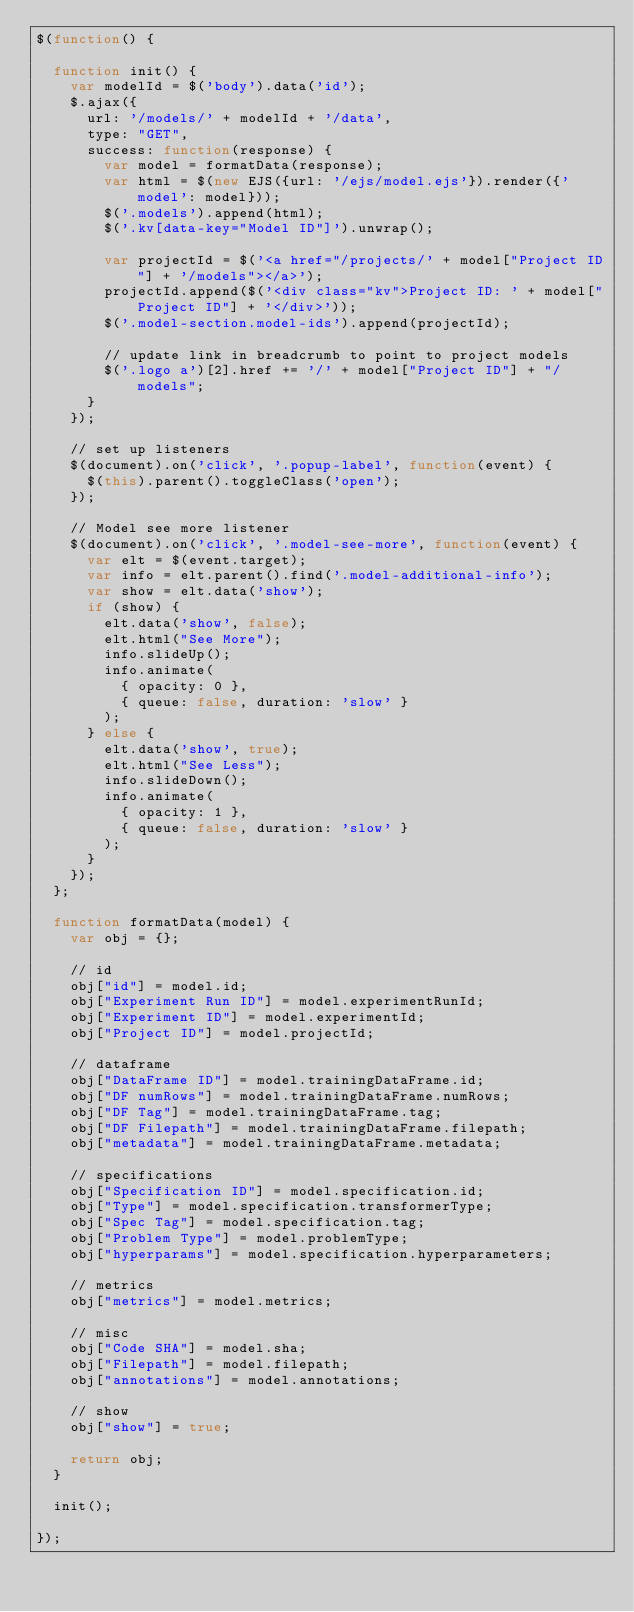Convert code to text. <code><loc_0><loc_0><loc_500><loc_500><_JavaScript_>$(function() {

  function init() {
    var modelId = $('body').data('id');
    $.ajax({
      url: '/models/' + modelId + '/data',
      type: "GET",
      success: function(response) {
        var model = formatData(response);
        var html = $(new EJS({url: '/ejs/model.ejs'}).render({'model': model}));
        $('.models').append(html);
        $('.kv[data-key="Model ID"]').unwrap();

        var projectId = $('<a href="/projects/' + model["Project ID"] + '/models"></a>');
        projectId.append($('<div class="kv">Project ID: ' + model["Project ID"] + '</div>'));
        $('.model-section.model-ids').append(projectId);

        // update link in breadcrumb to point to project models
        $('.logo a')[2].href += '/' + model["Project ID"] + "/models";
      }
    });

    // set up listeners
    $(document).on('click', '.popup-label', function(event) {
      $(this).parent().toggleClass('open');
    });

    // Model see more listener
    $(document).on('click', '.model-see-more', function(event) {
      var elt = $(event.target);
      var info = elt.parent().find('.model-additional-info');
      var show = elt.data('show');
      if (show) {
        elt.data('show', false);
        elt.html("See More");
        info.slideUp();
        info.animate(
          { opacity: 0 },
          { queue: false, duration: 'slow' }
        );
      } else {
        elt.data('show', true);
        elt.html("See Less");
        info.slideDown();
        info.animate(
          { opacity: 1 },
          { queue: false, duration: 'slow' }
        );
      }
    });
  };

  function formatData(model) {
    var obj = {};

    // id
    obj["id"] = model.id;
    obj["Experiment Run ID"] = model.experimentRunId;
    obj["Experiment ID"] = model.experimentId;
    obj["Project ID"] = model.projectId;

    // dataframe
    obj["DataFrame ID"] = model.trainingDataFrame.id;
    obj["DF numRows"] = model.trainingDataFrame.numRows;
    obj["DF Tag"] = model.trainingDataFrame.tag;
    obj["DF Filepath"] = model.trainingDataFrame.filepath;
    obj["metadata"] = model.trainingDataFrame.metadata;

    // specifications
    obj["Specification ID"] = model.specification.id;
    obj["Type"] = model.specification.transformerType;
    obj["Spec Tag"] = model.specification.tag;
    obj["Problem Type"] = model.problemType;
    obj["hyperparams"] = model.specification.hyperparameters;

    // metrics
    obj["metrics"] = model.metrics;

    // misc
    obj["Code SHA"] = model.sha;
    obj["Filepath"] = model.filepath;
    obj["annotations"] = model.annotations;

    // show
    obj["show"] = true;

    return obj;
  }

  init();

});</code> 